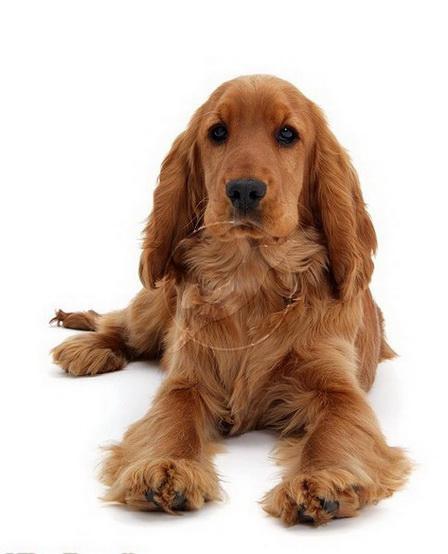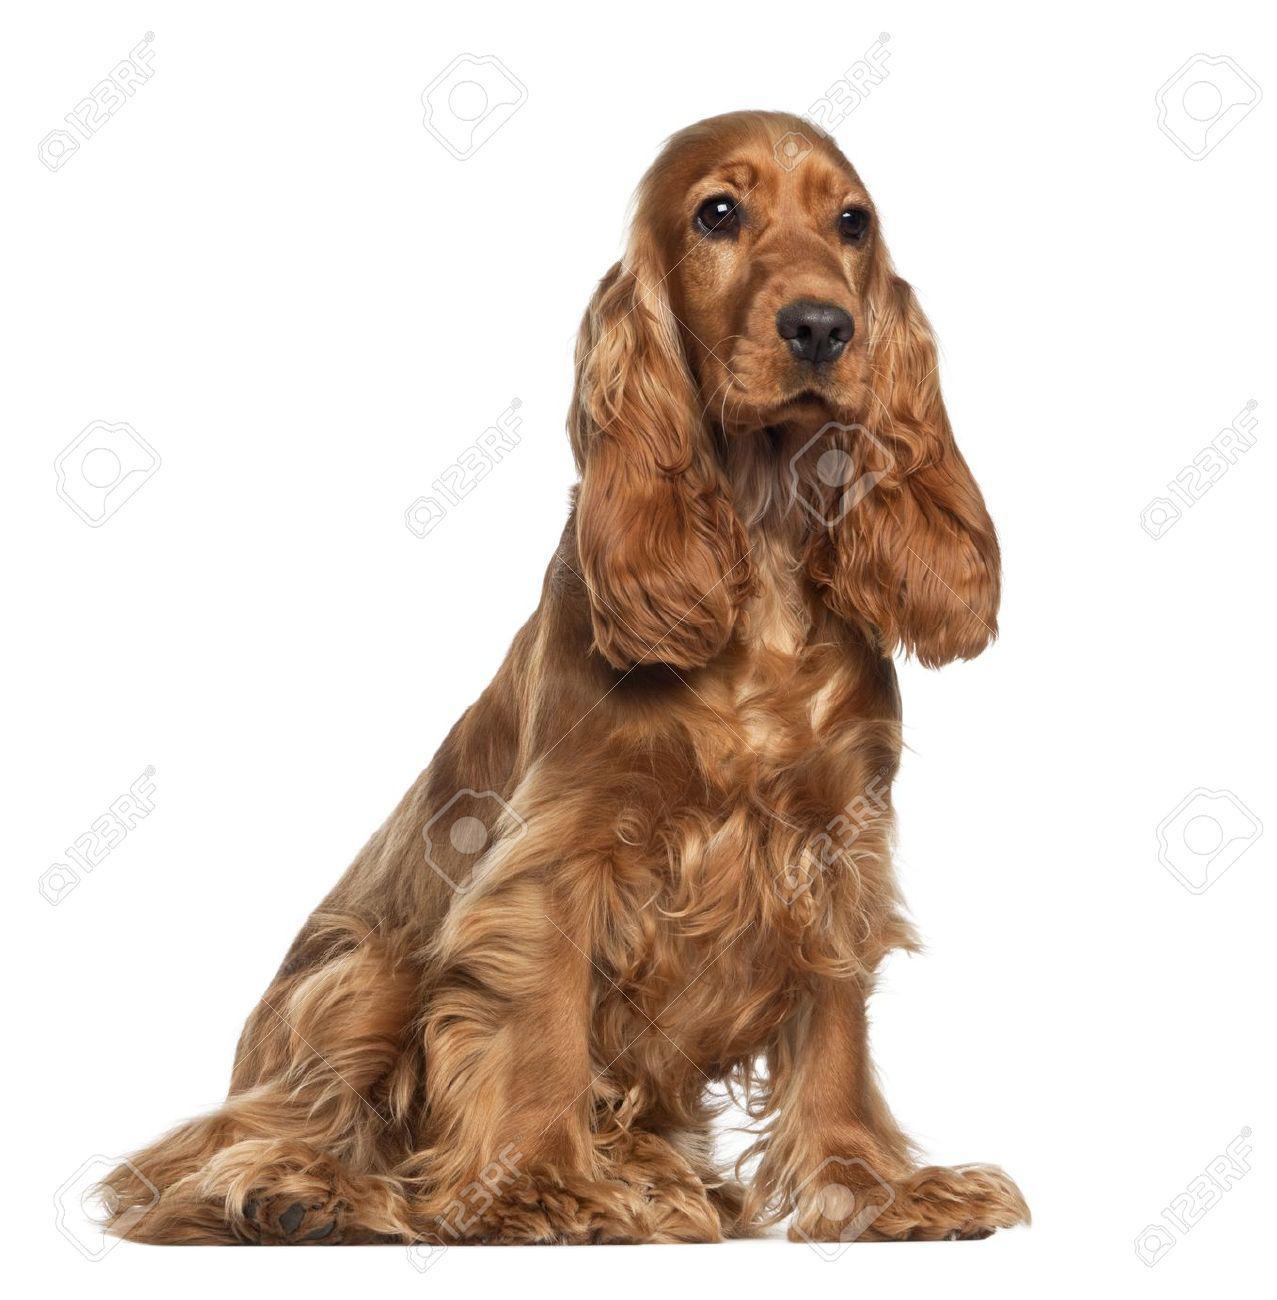The first image is the image on the left, the second image is the image on the right. Analyze the images presented: Is the assertion "One image contains a 'ginger' cocker spaniel sitting upright, and the other contains a 'ginger' cocker spaniel in a reclining pose." valid? Answer yes or no. Yes. The first image is the image on the left, the second image is the image on the right. Analyze the images presented: Is the assertion "One dog is sitting and one is laying down." valid? Answer yes or no. Yes. 